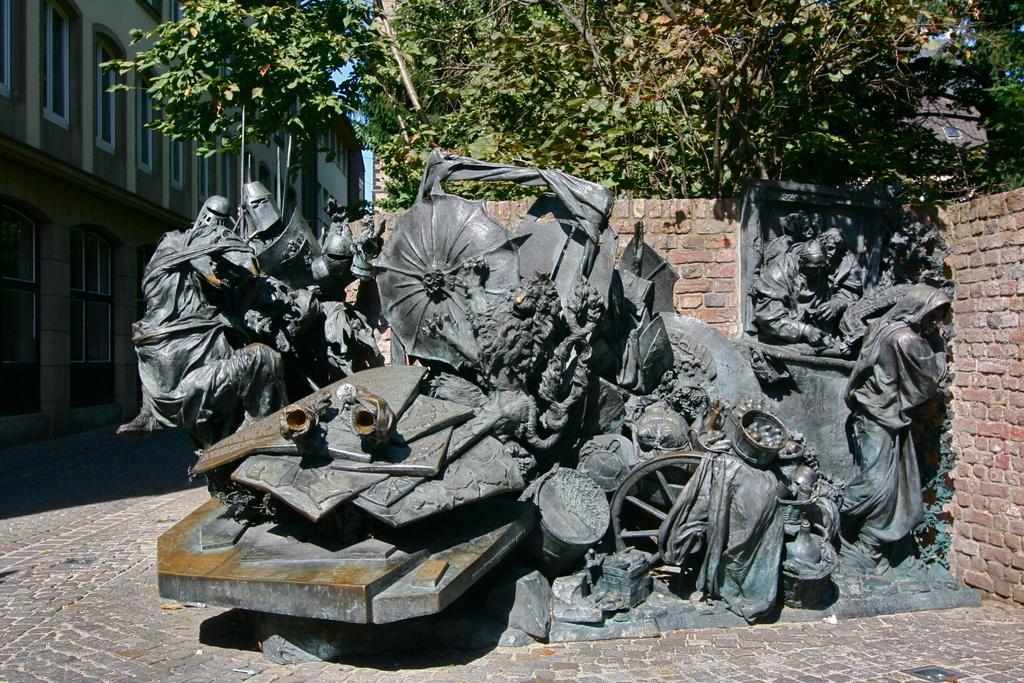Describe this image in one or two sentences. Here we can see statues on the surface. Here there is a brick wall and trees. Left side of the image, we can see buildings with walls and windows. 